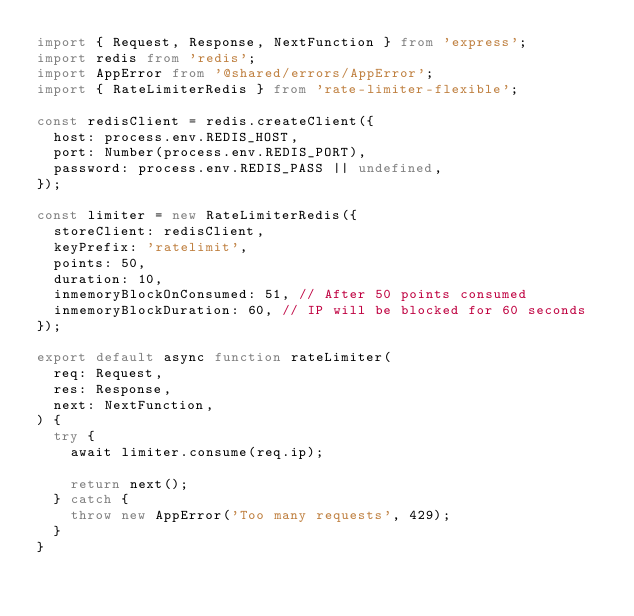Convert code to text. <code><loc_0><loc_0><loc_500><loc_500><_TypeScript_>import { Request, Response, NextFunction } from 'express';
import redis from 'redis';
import AppError from '@shared/errors/AppError';
import { RateLimiterRedis } from 'rate-limiter-flexible';

const redisClient = redis.createClient({
  host: process.env.REDIS_HOST,
  port: Number(process.env.REDIS_PORT),
  password: process.env.REDIS_PASS || undefined,
});

const limiter = new RateLimiterRedis({
  storeClient: redisClient,
  keyPrefix: 'ratelimit',
  points: 50,
  duration: 10,
  inmemoryBlockOnConsumed: 51, // After 50 points consumed
  inmemoryBlockDuration: 60, // IP will be blocked for 60 seconds
});

export default async function rateLimiter(
  req: Request,
  res: Response,
  next: NextFunction,
) {
  try {
    await limiter.consume(req.ip);

    return next();
  } catch {
    throw new AppError('Too many requests', 429);
  }
}
</code> 